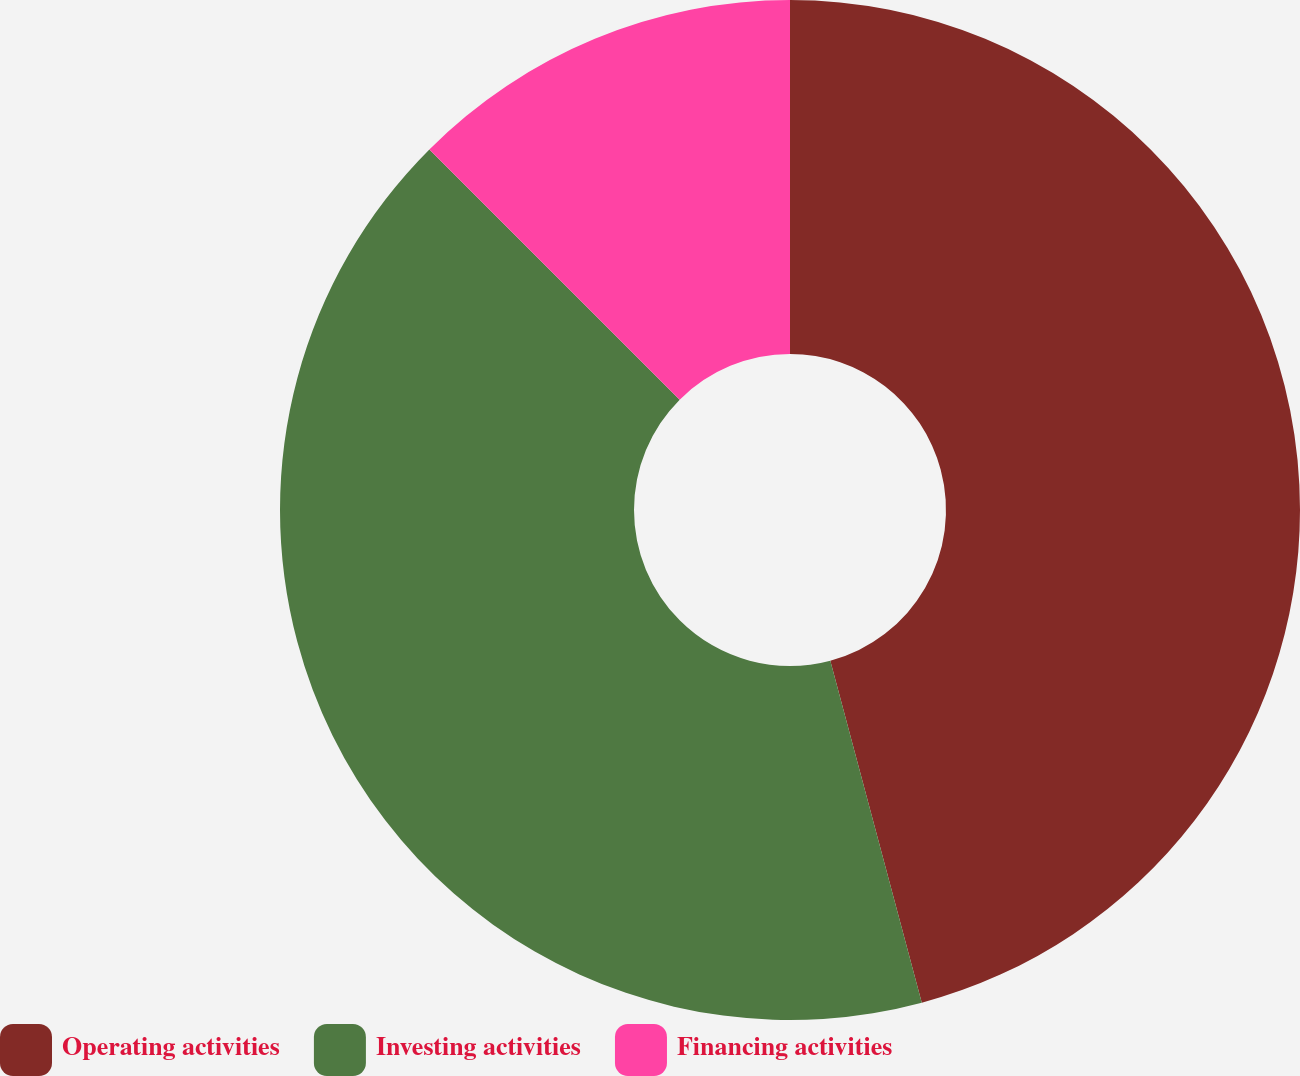Convert chart to OTSL. <chart><loc_0><loc_0><loc_500><loc_500><pie_chart><fcel>Operating activities<fcel>Investing activities<fcel>Financing activities<nl><fcel>45.84%<fcel>41.66%<fcel>12.5%<nl></chart> 